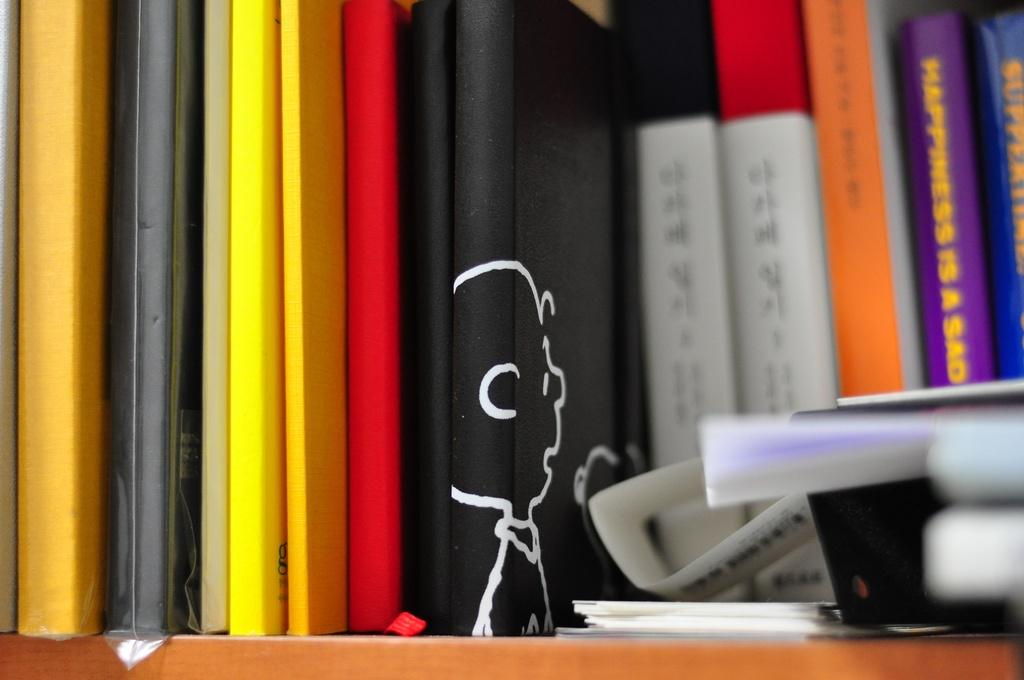Provide a one-sentence caption for the provided image. A bookshelf full of books, one book begins with Happiness is a sad. 